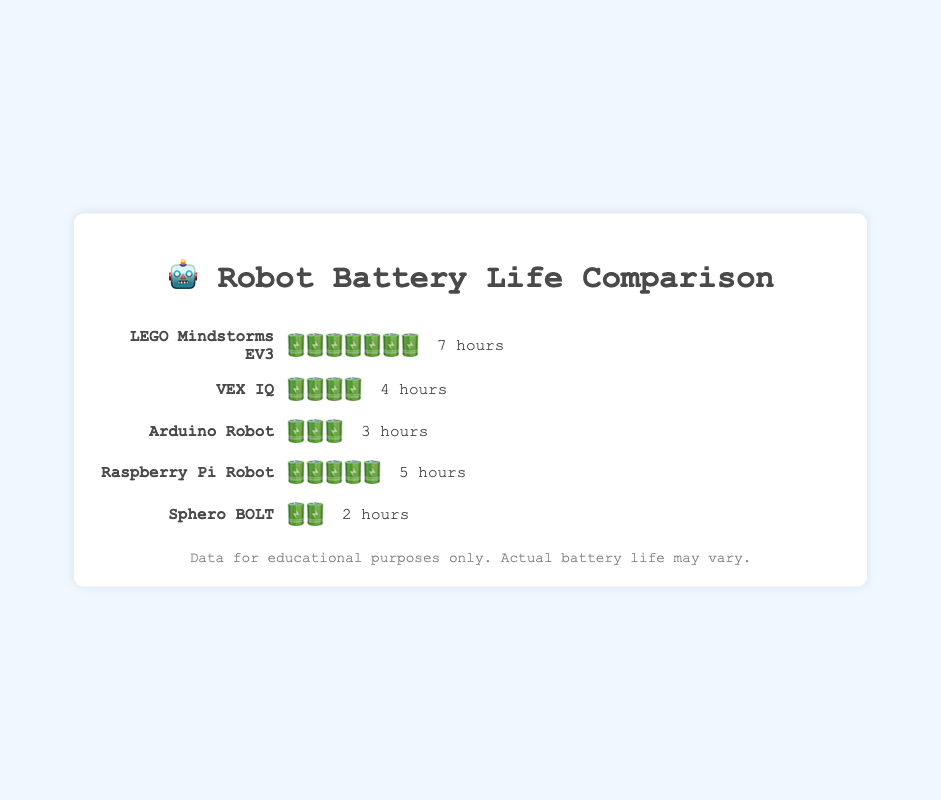What is the total battery life for all robot types combined? Sum the battery life of all robot types: (7 + 4 + 3 + 5 + 2). This equals 21 hours.
Answer: 21 hours Which robot has the shortest battery life? Identify the robot with the fewest battery emojis, which is Sphero BOLT with 2 battery emojis.
Answer: Sphero BOLT How many hours more does LEGO Mindstorms EV3 last compared to Arduino Robot? Subtract the battery life of Arduino Robot from LEGO Mindstorms EV3 (7 hours - 3 hours). This equals 4 hours.
Answer: 4 hours What is the average battery life of all robots? Sum the battery life of all robots (21 hours), then divide by the number of robots (5). The average is 21 / 5 = 4.2 hours.
Answer: 4.2 hours Which robot has the second-longest battery life? The longest battery life is LEGO Mindstorms EV3 with 7 hours, followed by Raspberry Pi Robot with 5 hours.
Answer: Raspberry Pi Robot Compare the battery life between the robots that have exactly 3 battery emojis and those that have exactly 4. The robots with 3 battery emojis (Arduino Robot) have a total of 3 hours. The robot with 4 battery emojis (VEX IQ) has 4 hours.
Answer: Arduino Robot: 3 hours, VEX IQ: 4 hours If you combine the battery life of VEX IQ and Sphero BOLT, how many hours do they provide together? Add the battery life of VEX IQ (4 hours) and Sphero BOLT (2 hours). This equals 6 hours.
Answer: 6 hours Which robot has more battery life, Raspberry Pi Robot or Arduino Robot, and by how much? Compare the battery life of Raspberry Pi Robot (5 hours) with Arduino Robot (3 hours). Raspberry Pi Robot has 2 more hours.
Answer: Raspberry Pi Robot by 2 hours What is the total amount of battery emojis displayed for all robots? Add all battery emojis: LEGO Mindstorms EV3 (7) + VEX IQ (4) + Arduino Robot (3) + Raspberry Pi Robot (5) + Sphero BOLT (2). This totals 21 emojis.
Answer: 21 emojis How much does the total battery life decrease if you exclude the robot with the longest battery life? Subtract the battery life of LEGO Mindstorms EV3 (7 hours) from the total battery life of all robots (21 hours). This equals 14 hours.
Answer: 14 hours 